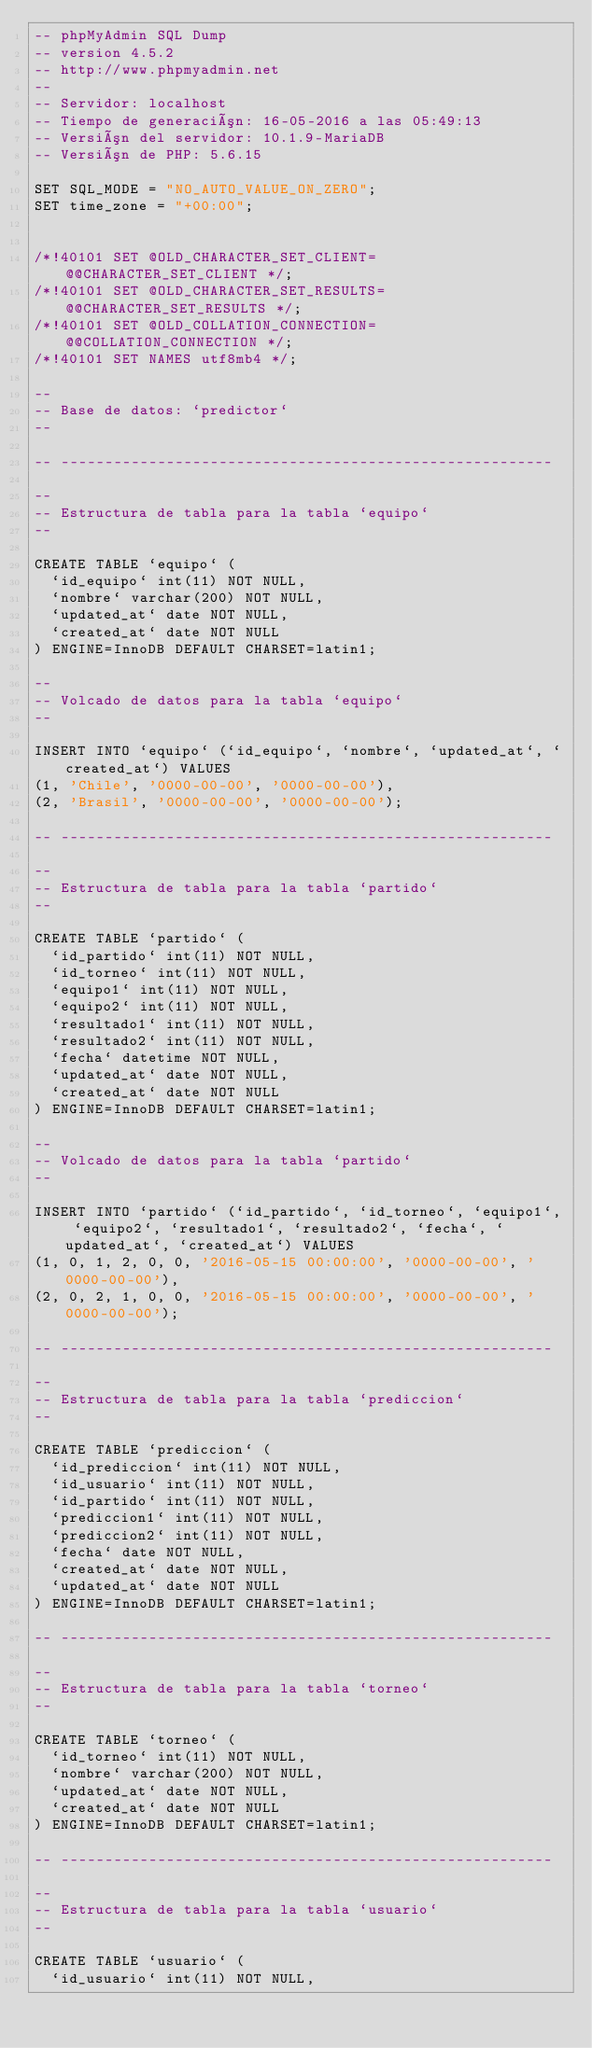Convert code to text. <code><loc_0><loc_0><loc_500><loc_500><_SQL_>-- phpMyAdmin SQL Dump
-- version 4.5.2
-- http://www.phpmyadmin.net
--
-- Servidor: localhost
-- Tiempo de generación: 16-05-2016 a las 05:49:13
-- Versión del servidor: 10.1.9-MariaDB
-- Versión de PHP: 5.6.15

SET SQL_MODE = "NO_AUTO_VALUE_ON_ZERO";
SET time_zone = "+00:00";


/*!40101 SET @OLD_CHARACTER_SET_CLIENT=@@CHARACTER_SET_CLIENT */;
/*!40101 SET @OLD_CHARACTER_SET_RESULTS=@@CHARACTER_SET_RESULTS */;
/*!40101 SET @OLD_COLLATION_CONNECTION=@@COLLATION_CONNECTION */;
/*!40101 SET NAMES utf8mb4 */;

--
-- Base de datos: `predictor`
--

-- --------------------------------------------------------

--
-- Estructura de tabla para la tabla `equipo`
--

CREATE TABLE `equipo` (
  `id_equipo` int(11) NOT NULL,
  `nombre` varchar(200) NOT NULL,
  `updated_at` date NOT NULL,
  `created_at` date NOT NULL
) ENGINE=InnoDB DEFAULT CHARSET=latin1;

--
-- Volcado de datos para la tabla `equipo`
--

INSERT INTO `equipo` (`id_equipo`, `nombre`, `updated_at`, `created_at`) VALUES
(1, 'Chile', '0000-00-00', '0000-00-00'),
(2, 'Brasil', '0000-00-00', '0000-00-00');

-- --------------------------------------------------------

--
-- Estructura de tabla para la tabla `partido`
--

CREATE TABLE `partido` (
  `id_partido` int(11) NOT NULL,
  `id_torneo` int(11) NOT NULL,
  `equipo1` int(11) NOT NULL,
  `equipo2` int(11) NOT NULL,
  `resultado1` int(11) NOT NULL,
  `resultado2` int(11) NOT NULL,
  `fecha` datetime NOT NULL,
  `updated_at` date NOT NULL,
  `created_at` date NOT NULL
) ENGINE=InnoDB DEFAULT CHARSET=latin1;

--
-- Volcado de datos para la tabla `partido`
--

INSERT INTO `partido` (`id_partido`, `id_torneo`, `equipo1`, `equipo2`, `resultado1`, `resultado2`, `fecha`, `updated_at`, `created_at`) VALUES
(1, 0, 1, 2, 0, 0, '2016-05-15 00:00:00', '0000-00-00', '0000-00-00'),
(2, 0, 2, 1, 0, 0, '2016-05-15 00:00:00', '0000-00-00', '0000-00-00');

-- --------------------------------------------------------

--
-- Estructura de tabla para la tabla `prediccion`
--

CREATE TABLE `prediccion` (
  `id_prediccion` int(11) NOT NULL,
  `id_usuario` int(11) NOT NULL,
  `id_partido` int(11) NOT NULL,
  `prediccion1` int(11) NOT NULL,
  `prediccion2` int(11) NOT NULL,
  `fecha` date NOT NULL,
  `created_at` date NOT NULL,
  `updated_at` date NOT NULL
) ENGINE=InnoDB DEFAULT CHARSET=latin1;

-- --------------------------------------------------------

--
-- Estructura de tabla para la tabla `torneo`
--

CREATE TABLE `torneo` (
  `id_torneo` int(11) NOT NULL,
  `nombre` varchar(200) NOT NULL,
  `updated_at` date NOT NULL,
  `created_at` date NOT NULL
) ENGINE=InnoDB DEFAULT CHARSET=latin1;

-- --------------------------------------------------------

--
-- Estructura de tabla para la tabla `usuario`
--

CREATE TABLE `usuario` (
  `id_usuario` int(11) NOT NULL,</code> 